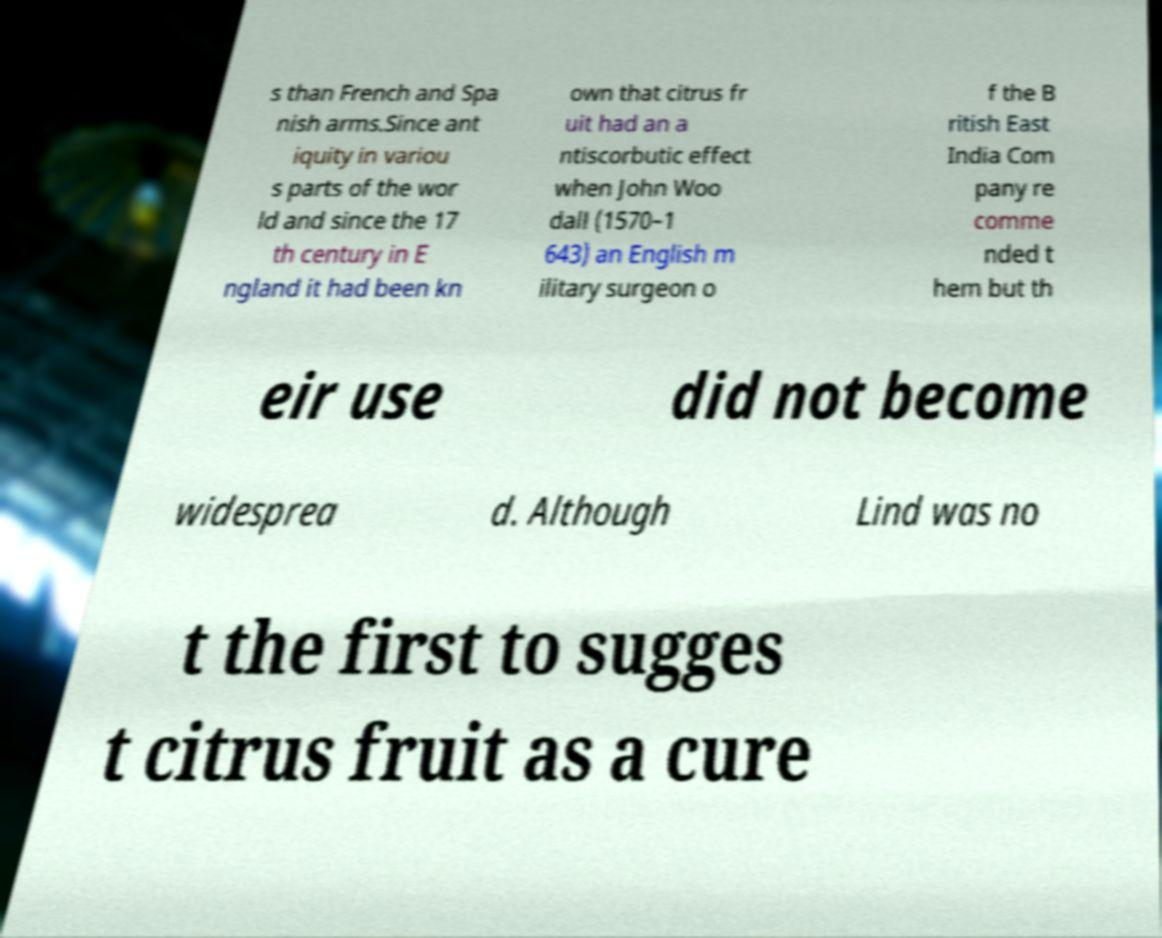Can you read and provide the text displayed in the image?This photo seems to have some interesting text. Can you extract and type it out for me? s than French and Spa nish arms.Since ant iquity in variou s parts of the wor ld and since the 17 th century in E ngland it had been kn own that citrus fr uit had an a ntiscorbutic effect when John Woo dall (1570–1 643) an English m ilitary surgeon o f the B ritish East India Com pany re comme nded t hem but th eir use did not become widesprea d. Although Lind was no t the first to sugges t citrus fruit as a cure 